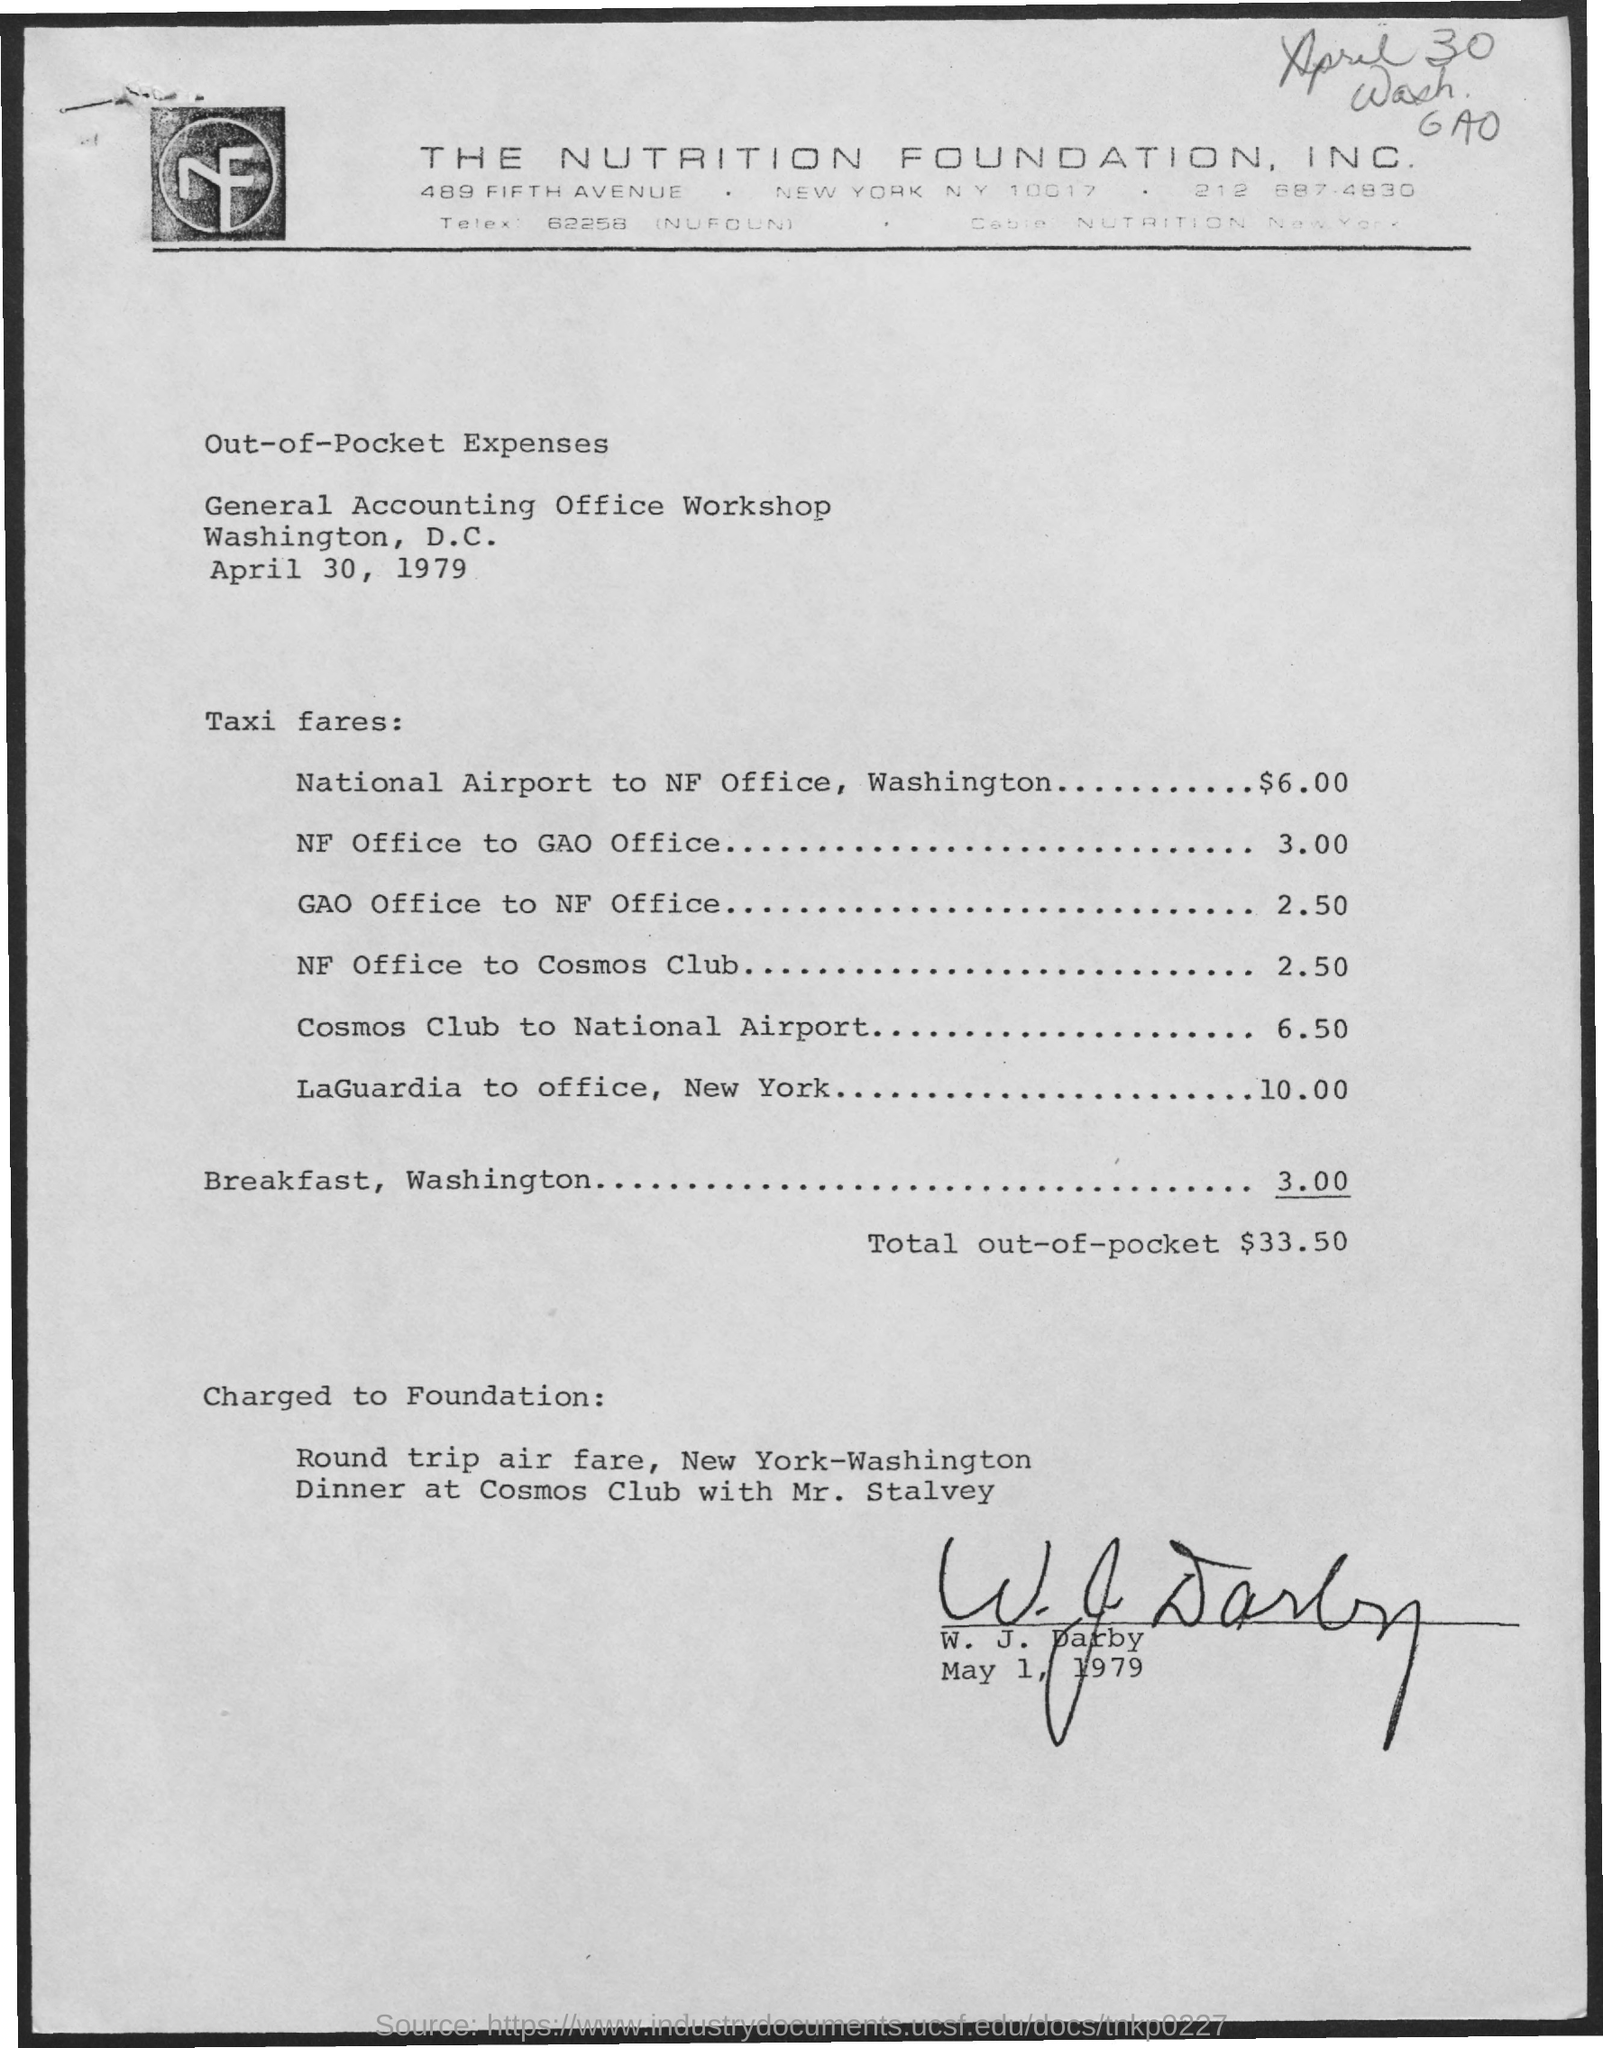What is the total out-of-pocket?
Your answer should be very brief. $33.50. To which company does this letterhead belong to?
Make the answer very short. The Nutrition Foundation, Inc. What is taxi fares from national airport to np office, washington?
Your answer should be very brief. 6.00. What is the amount spend for breakfast, washington?
Ensure brevity in your answer.  3.00. 